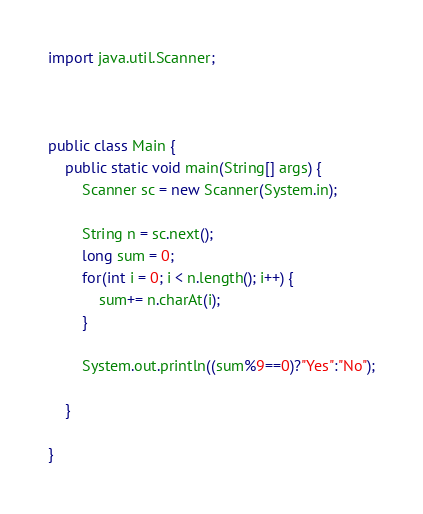<code> <loc_0><loc_0><loc_500><loc_500><_Java_>import java.util.Scanner;



public class Main {
	public static void main(String[] args) {
		Scanner sc = new Scanner(System.in);
	
		String n = sc.next();
		long sum = 0;
		for(int i = 0; i < n.length(); i++) {
			sum+= n.charAt(i);
		}
		
		System.out.println((sum%9==0)?"Yes":"No");
		
	}
	
}

</code> 